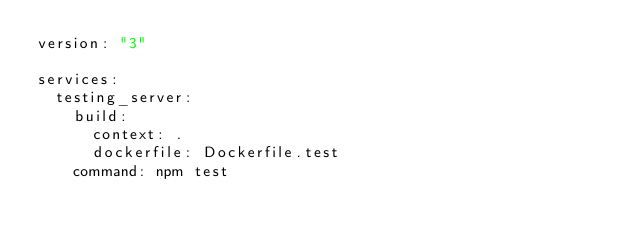<code> <loc_0><loc_0><loc_500><loc_500><_YAML_>version: "3"

services:
  testing_server:
    build:
      context: .
      dockerfile: Dockerfile.test
    command: npm test
</code> 